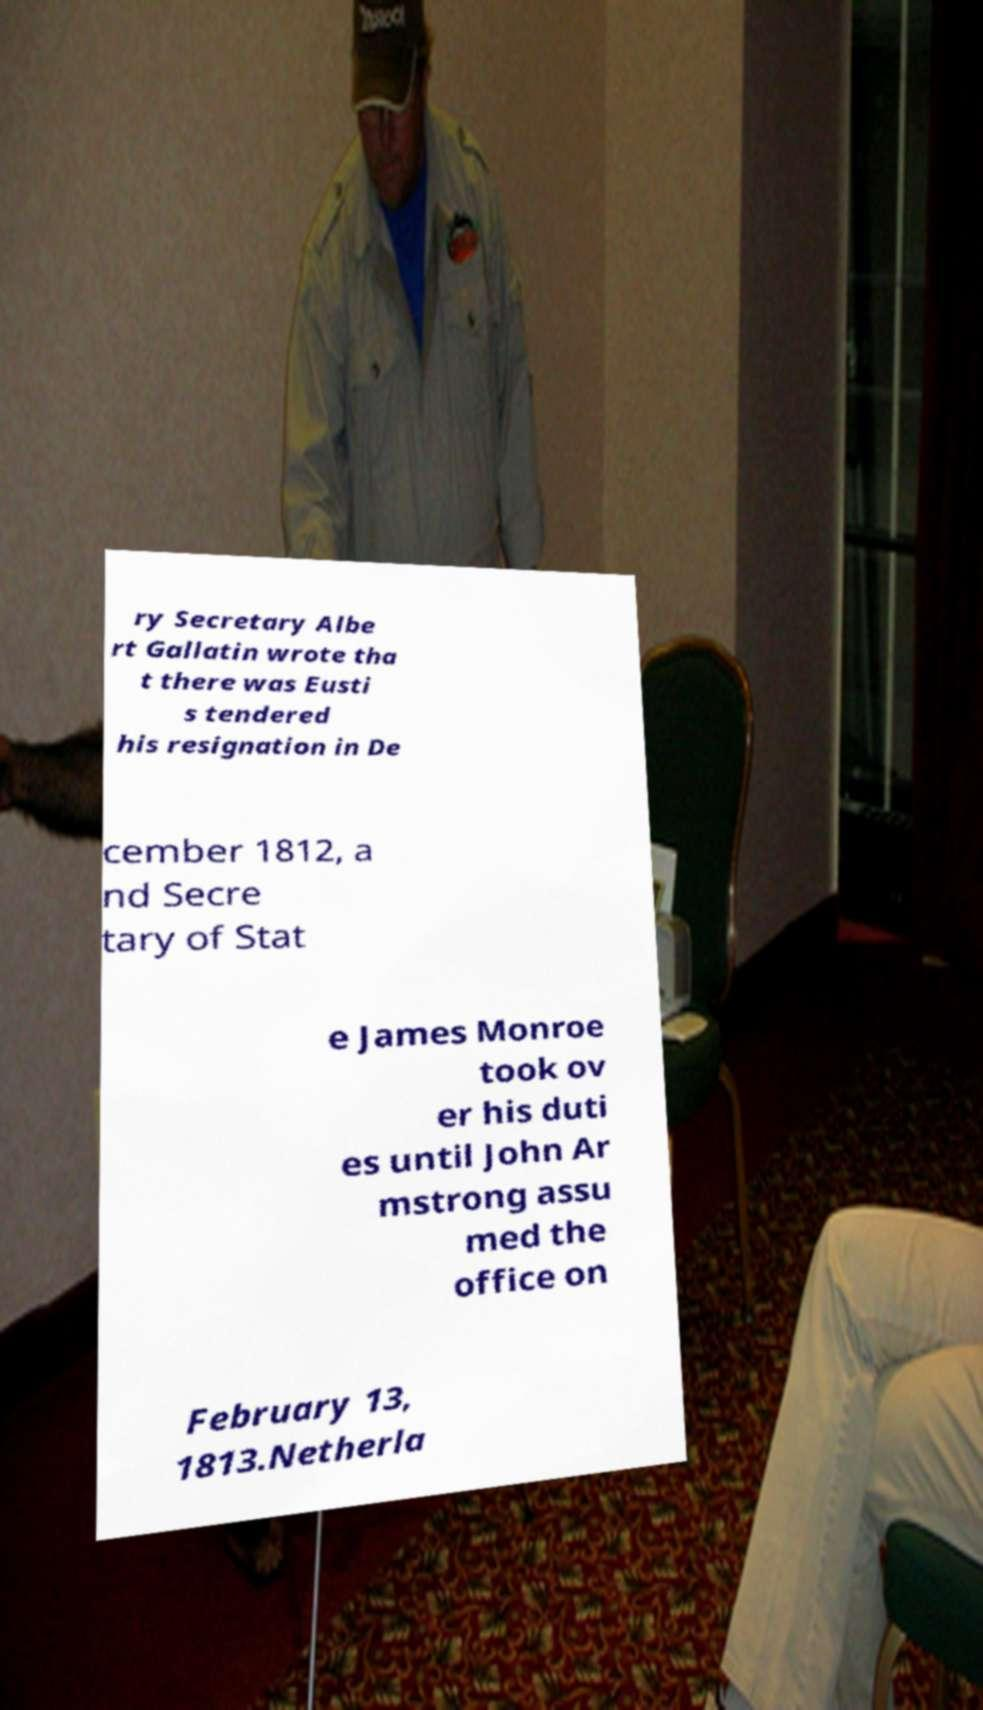Can you read and provide the text displayed in the image?This photo seems to have some interesting text. Can you extract and type it out for me? ry Secretary Albe rt Gallatin wrote tha t there was Eusti s tendered his resignation in De cember 1812, a nd Secre tary of Stat e James Monroe took ov er his duti es until John Ar mstrong assu med the office on February 13, 1813.Netherla 